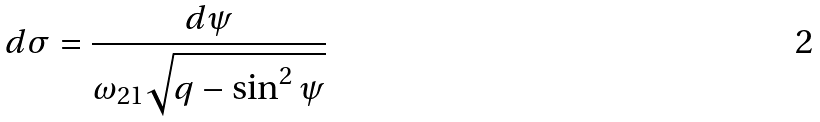<formula> <loc_0><loc_0><loc_500><loc_500>d \sigma = \frac { d \psi } { \omega _ { 2 1 } \sqrt { q - \sin ^ { 2 } \psi } }</formula> 